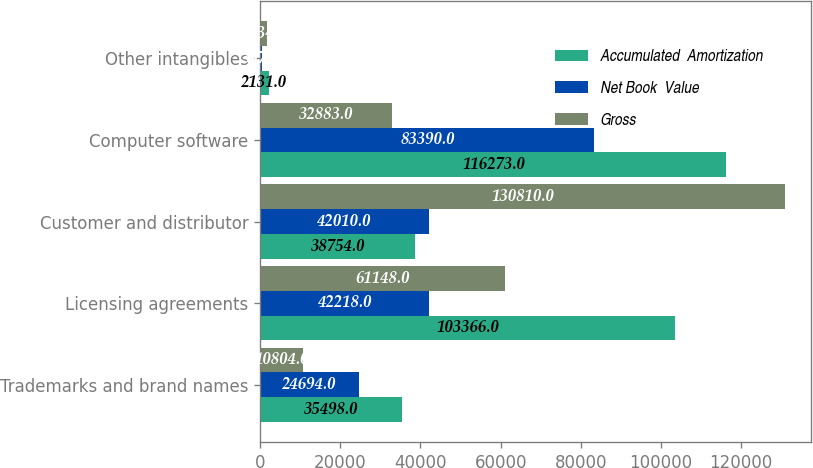<chart> <loc_0><loc_0><loc_500><loc_500><stacked_bar_chart><ecel><fcel>Trademarks and brand names<fcel>Licensing agreements<fcel>Customer and distributor<fcel>Computer software<fcel>Other intangibles<nl><fcel>Accumulated  Amortization<fcel>35498<fcel>103366<fcel>38754<fcel>116273<fcel>2131<nl><fcel>Net Book  Value<fcel>24694<fcel>42218<fcel>42010<fcel>83390<fcel>397<nl><fcel>Gross<fcel>10804<fcel>61148<fcel>130810<fcel>32883<fcel>1734<nl></chart> 